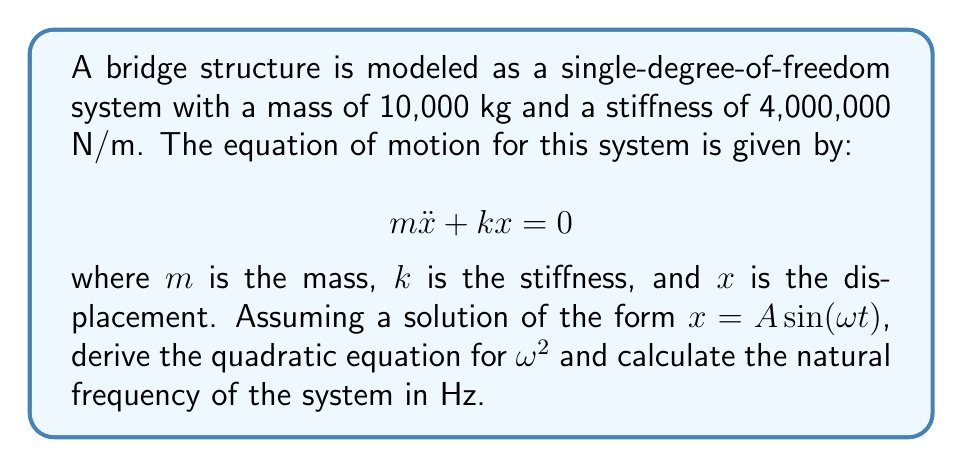Show me your answer to this math problem. 1. Start with the equation of motion:
   $$ m\ddot{x} + kx = 0 $$

2. Assume a solution of the form $x = A\sin(\omega t)$. The second derivative of this is:
   $$ \ddot{x} = -A\omega^2\sin(\omega t) $$

3. Substitute these into the equation of motion:
   $$ -m A\omega^2\sin(\omega t) + k A\sin(\omega t) = 0 $$

4. Factor out $A\sin(\omega t)$:
   $$ A\sin(\omega t)(-m\omega^2 + k) = 0 $$

5. For this to be true for all $t$, we must have:
   $$ -m\omega^2 + k = 0 $$

6. Rearrange to get the quadratic equation for $\omega^2$:
   $$ m\omega^2 = k $$
   $$ \omega^2 = \frac{k}{m} $$

7. Substitute the given values:
   $$ \omega^2 = \frac{4,000,000 \text{ N/m}}{10,000 \text{ kg}} = 400 \text{ s}^{-2} $$

8. Take the square root to find $\omega$:
   $$ \omega = \sqrt{400} = 20 \text{ rad/s} $$

9. Convert to frequency in Hz:
   $$ f = \frac{\omega}{2\pi} = \frac{20}{2\pi} \approx 3.18 \text{ Hz} $$
Answer: 3.18 Hz 